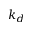Convert formula to latex. <formula><loc_0><loc_0><loc_500><loc_500>k _ { d }</formula> 